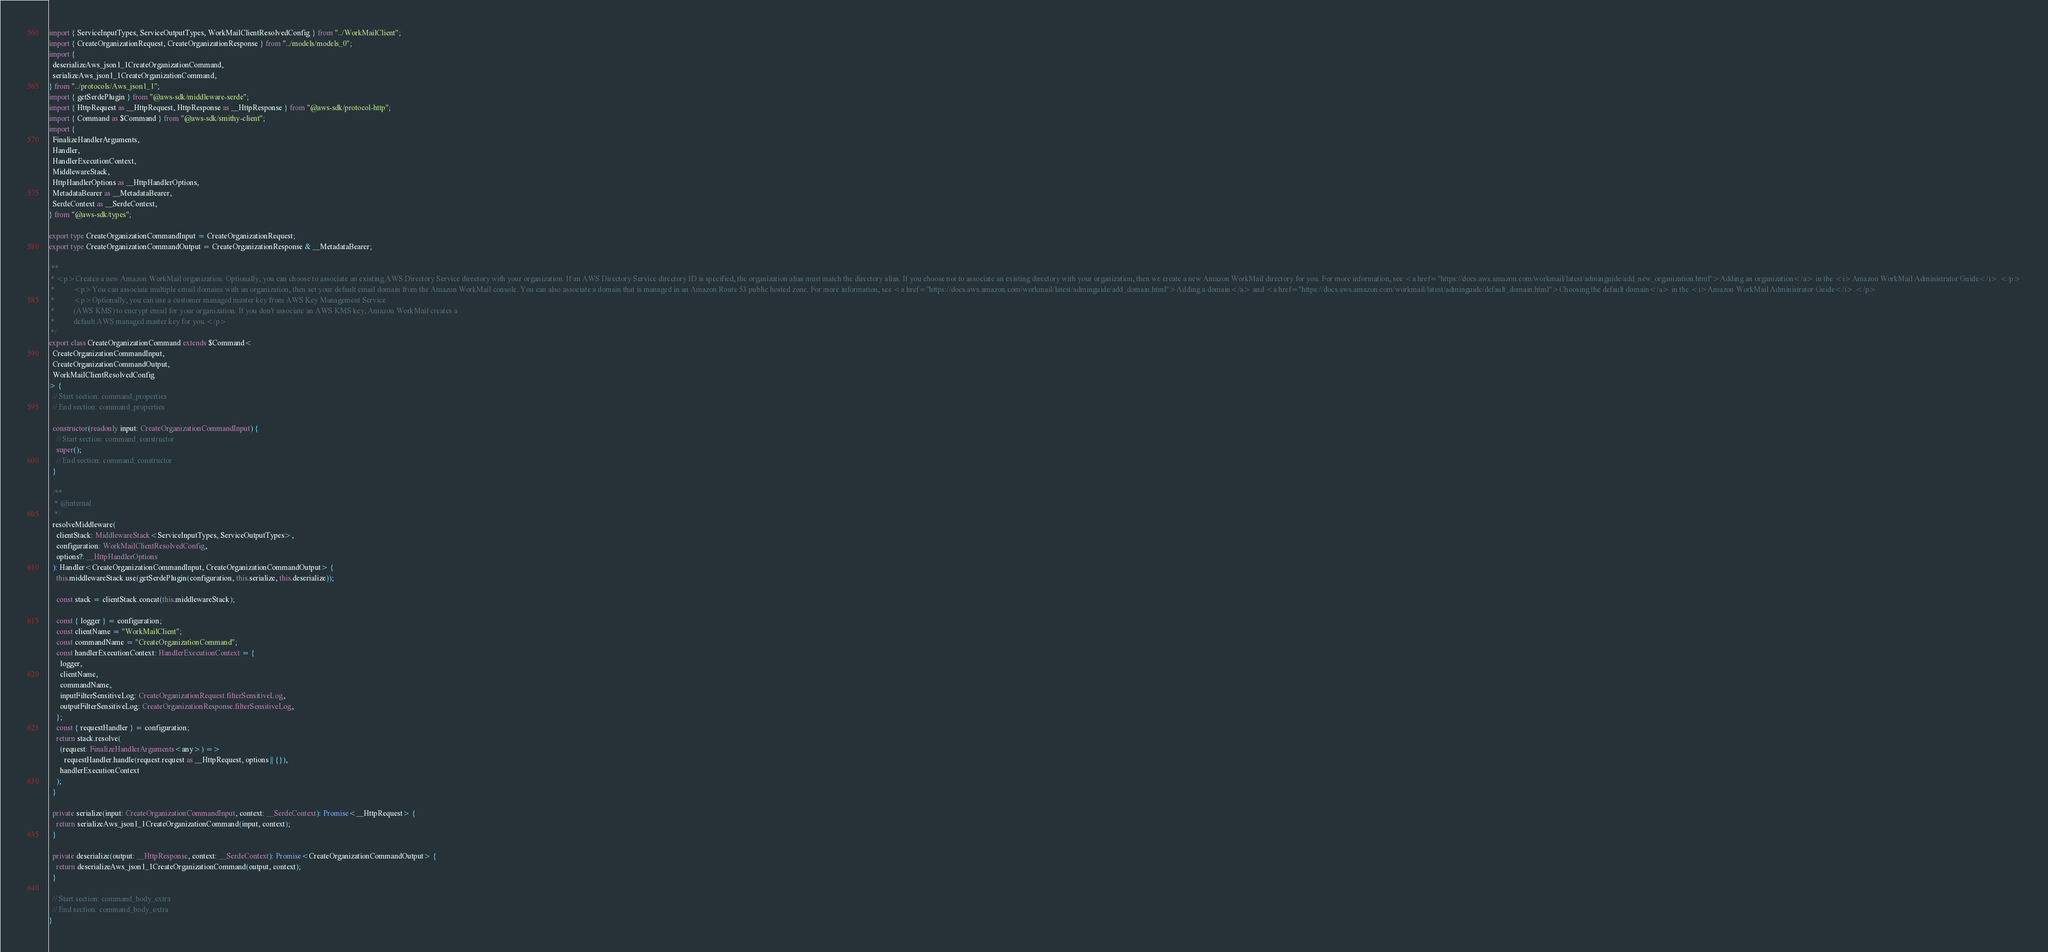<code> <loc_0><loc_0><loc_500><loc_500><_TypeScript_>import { ServiceInputTypes, ServiceOutputTypes, WorkMailClientResolvedConfig } from "../WorkMailClient";
import { CreateOrganizationRequest, CreateOrganizationResponse } from "../models/models_0";
import {
  deserializeAws_json1_1CreateOrganizationCommand,
  serializeAws_json1_1CreateOrganizationCommand,
} from "../protocols/Aws_json1_1";
import { getSerdePlugin } from "@aws-sdk/middleware-serde";
import { HttpRequest as __HttpRequest, HttpResponse as __HttpResponse } from "@aws-sdk/protocol-http";
import { Command as $Command } from "@aws-sdk/smithy-client";
import {
  FinalizeHandlerArguments,
  Handler,
  HandlerExecutionContext,
  MiddlewareStack,
  HttpHandlerOptions as __HttpHandlerOptions,
  MetadataBearer as __MetadataBearer,
  SerdeContext as __SerdeContext,
} from "@aws-sdk/types";

export type CreateOrganizationCommandInput = CreateOrganizationRequest;
export type CreateOrganizationCommandOutput = CreateOrganizationResponse & __MetadataBearer;

/**
 * <p>Creates a new Amazon WorkMail organization. Optionally, you can choose to associate an existing AWS Directory Service directory with your organization. If an AWS Directory Service directory ID is specified, the organization alias must match the directory alias. If you choose not to associate an existing directory with your organization, then we create a new Amazon WorkMail directory for you. For more information, see <a href="https://docs.aws.amazon.com/workmail/latest/adminguide/add_new_organization.html">Adding an organization</a> in the <i>Amazon WorkMail Administrator Guide</i>.</p>
 *          <p>You can associate multiple email domains with an organization, then set your default email domain from the Amazon WorkMail console. You can also associate a domain that is managed in an Amazon Route 53 public hosted zone. For more information, see <a href="https://docs.aws.amazon.com/workmail/latest/adminguide/add_domain.html">Adding a domain</a> and <a href="https://docs.aws.amazon.com/workmail/latest/adminguide/default_domain.html">Choosing the default domain</a> in the <i>Amazon WorkMail Administrator Guide</i>.</p>
 *          <p>Optionally, you can use a customer managed master key from AWS Key Management Service
 *          (AWS KMS) to encrypt email for your organization. If you don't associate an AWS KMS key, Amazon WorkMail creates a
 *          default AWS managed master key for you.</p>
 */
export class CreateOrganizationCommand extends $Command<
  CreateOrganizationCommandInput,
  CreateOrganizationCommandOutput,
  WorkMailClientResolvedConfig
> {
  // Start section: command_properties
  // End section: command_properties

  constructor(readonly input: CreateOrganizationCommandInput) {
    // Start section: command_constructor
    super();
    // End section: command_constructor
  }

  /**
   * @internal
   */
  resolveMiddleware(
    clientStack: MiddlewareStack<ServiceInputTypes, ServiceOutputTypes>,
    configuration: WorkMailClientResolvedConfig,
    options?: __HttpHandlerOptions
  ): Handler<CreateOrganizationCommandInput, CreateOrganizationCommandOutput> {
    this.middlewareStack.use(getSerdePlugin(configuration, this.serialize, this.deserialize));

    const stack = clientStack.concat(this.middlewareStack);

    const { logger } = configuration;
    const clientName = "WorkMailClient";
    const commandName = "CreateOrganizationCommand";
    const handlerExecutionContext: HandlerExecutionContext = {
      logger,
      clientName,
      commandName,
      inputFilterSensitiveLog: CreateOrganizationRequest.filterSensitiveLog,
      outputFilterSensitiveLog: CreateOrganizationResponse.filterSensitiveLog,
    };
    const { requestHandler } = configuration;
    return stack.resolve(
      (request: FinalizeHandlerArguments<any>) =>
        requestHandler.handle(request.request as __HttpRequest, options || {}),
      handlerExecutionContext
    );
  }

  private serialize(input: CreateOrganizationCommandInput, context: __SerdeContext): Promise<__HttpRequest> {
    return serializeAws_json1_1CreateOrganizationCommand(input, context);
  }

  private deserialize(output: __HttpResponse, context: __SerdeContext): Promise<CreateOrganizationCommandOutput> {
    return deserializeAws_json1_1CreateOrganizationCommand(output, context);
  }

  // Start section: command_body_extra
  // End section: command_body_extra
}
</code> 